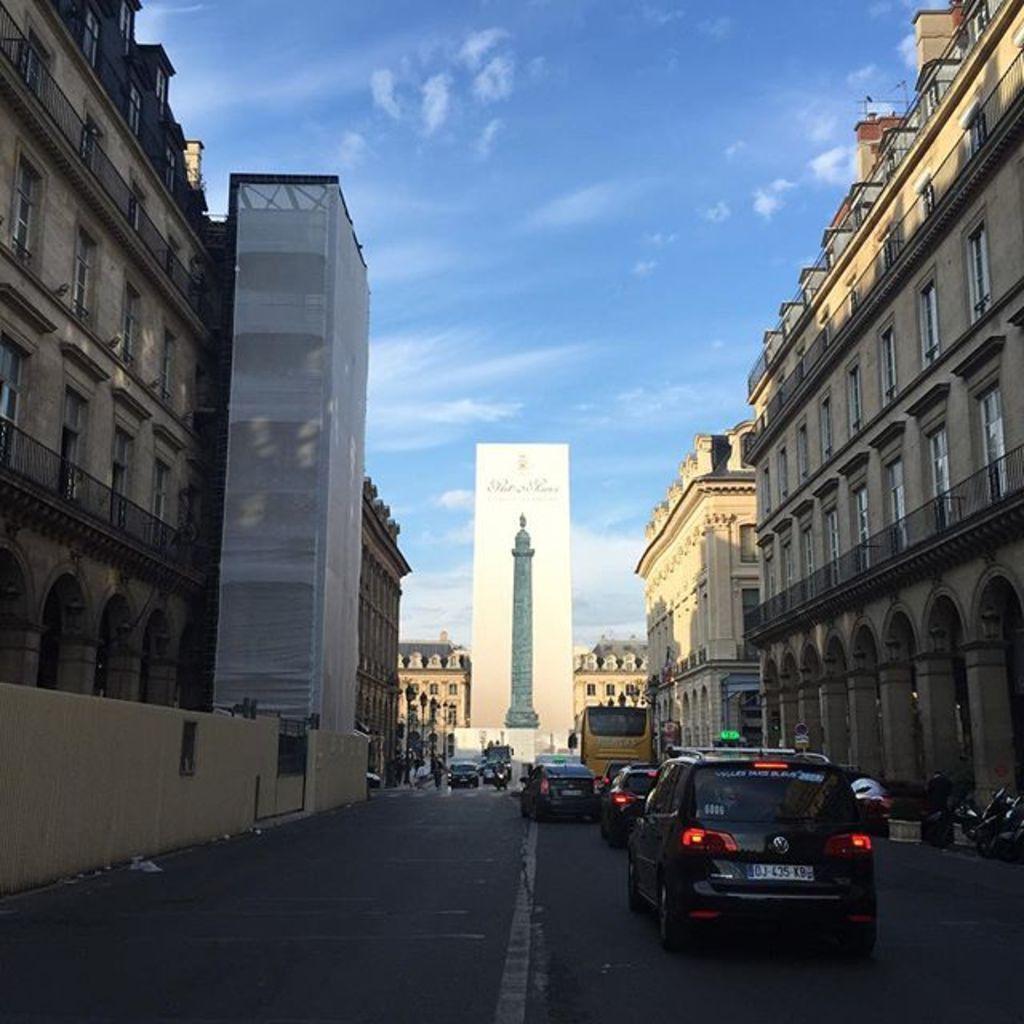Please provide a concise description of this image. At the bottom of this image, there are vehicles on the road. On both sides of this road, there are buildings. In the background, there is pole, there are buildings and there are clouds in the blue sky. 